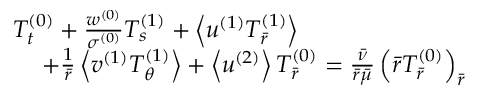<formula> <loc_0><loc_0><loc_500><loc_500>\begin{array} { r } { T _ { t } ^ { ( 0 ) } + \frac { w ^ { ( 0 ) } } { \sigma ^ { ( 0 ) } } T _ { s } ^ { ( 1 ) } + \left < u ^ { ( 1 ) } T _ { \bar { r } } ^ { ( 1 ) } \right > \quad } \\ { + \frac { 1 } { \bar { r } } \left < v ^ { ( 1 ) } T _ { \theta } ^ { ( 1 ) } \right > + \left < u ^ { ( 2 ) } \right > T _ { \bar { r } } ^ { ( 0 ) } = \frac { \bar { \nu } } { \bar { r } \bar { \mu } } \left ( \bar { r } T _ { \bar { r } } ^ { ( 0 ) } \right ) _ { \bar { r } } } \end{array}</formula> 